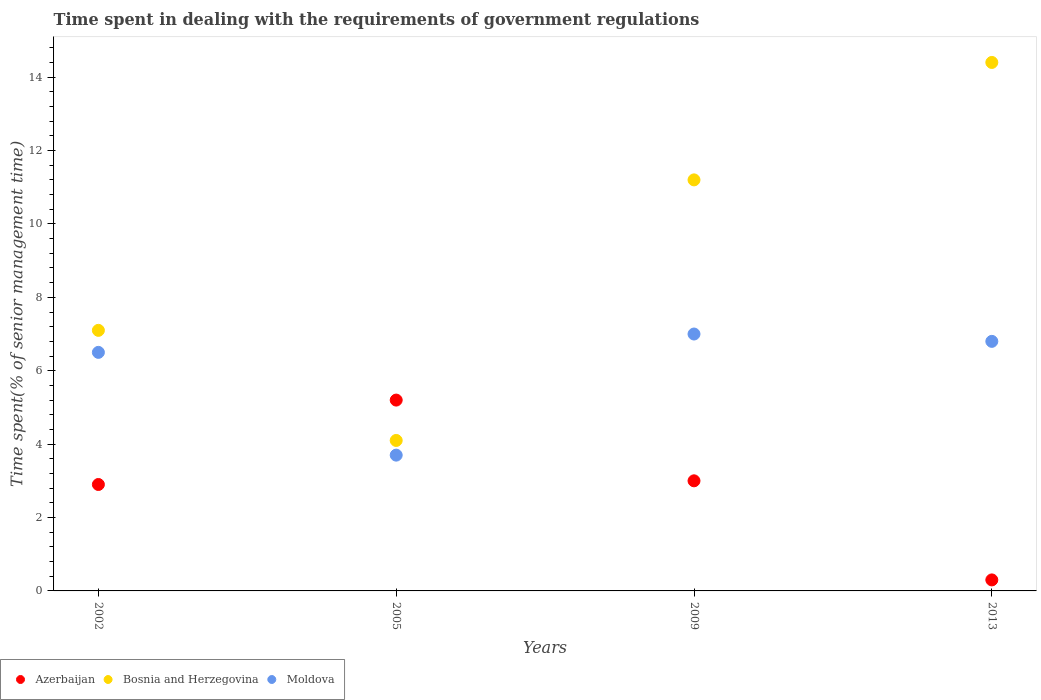How many different coloured dotlines are there?
Your answer should be very brief. 3. Is the number of dotlines equal to the number of legend labels?
Provide a succinct answer. Yes. Across all years, what is the minimum time spent while dealing with the requirements of government regulations in Moldova?
Your answer should be compact. 3.7. In how many years, is the time spent while dealing with the requirements of government regulations in Moldova greater than 0.8 %?
Keep it short and to the point. 4. Is the time spent while dealing with the requirements of government regulations in Moldova in 2002 less than that in 2013?
Offer a terse response. Yes. Is the difference between the time spent while dealing with the requirements of government regulations in Moldova in 2009 and 2013 greater than the difference between the time spent while dealing with the requirements of government regulations in Azerbaijan in 2009 and 2013?
Offer a terse response. No. What is the difference between the highest and the second highest time spent while dealing with the requirements of government regulations in Bosnia and Herzegovina?
Give a very brief answer. 3.2. Is the sum of the time spent while dealing with the requirements of government regulations in Bosnia and Herzegovina in 2002 and 2005 greater than the maximum time spent while dealing with the requirements of government regulations in Azerbaijan across all years?
Your response must be concise. Yes. How many dotlines are there?
Your answer should be compact. 3. What is the difference between two consecutive major ticks on the Y-axis?
Your response must be concise. 2. Does the graph contain any zero values?
Your response must be concise. No. Where does the legend appear in the graph?
Your answer should be compact. Bottom left. How many legend labels are there?
Offer a very short reply. 3. How are the legend labels stacked?
Keep it short and to the point. Horizontal. What is the title of the graph?
Give a very brief answer. Time spent in dealing with the requirements of government regulations. What is the label or title of the X-axis?
Your answer should be very brief. Years. What is the label or title of the Y-axis?
Offer a terse response. Time spent(% of senior management time). What is the Time spent(% of senior management time) in Bosnia and Herzegovina in 2002?
Your answer should be very brief. 7.1. What is the Time spent(% of senior management time) in Azerbaijan in 2005?
Provide a succinct answer. 5.2. What is the Time spent(% of senior management time) in Moldova in 2005?
Provide a succinct answer. 3.7. What is the Time spent(% of senior management time) of Azerbaijan in 2009?
Offer a very short reply. 3. What is the Time spent(% of senior management time) in Bosnia and Herzegovina in 2009?
Make the answer very short. 11.2. What is the Time spent(% of senior management time) in Moldova in 2009?
Offer a very short reply. 7. What is the Time spent(% of senior management time) of Azerbaijan in 2013?
Offer a terse response. 0.3. What is the Time spent(% of senior management time) in Bosnia and Herzegovina in 2013?
Keep it short and to the point. 14.4. Across all years, what is the maximum Time spent(% of senior management time) in Azerbaijan?
Make the answer very short. 5.2. Across all years, what is the maximum Time spent(% of senior management time) of Bosnia and Herzegovina?
Give a very brief answer. 14.4. Across all years, what is the maximum Time spent(% of senior management time) in Moldova?
Offer a terse response. 7. Across all years, what is the minimum Time spent(% of senior management time) of Bosnia and Herzegovina?
Your response must be concise. 4.1. What is the total Time spent(% of senior management time) of Azerbaijan in the graph?
Offer a terse response. 11.4. What is the total Time spent(% of senior management time) in Bosnia and Herzegovina in the graph?
Keep it short and to the point. 36.8. What is the difference between the Time spent(% of senior management time) of Moldova in 2002 and that in 2009?
Keep it short and to the point. -0.5. What is the difference between the Time spent(% of senior management time) in Azerbaijan in 2002 and that in 2013?
Keep it short and to the point. 2.6. What is the difference between the Time spent(% of senior management time) of Bosnia and Herzegovina in 2005 and that in 2009?
Your answer should be compact. -7.1. What is the difference between the Time spent(% of senior management time) of Moldova in 2005 and that in 2009?
Your answer should be compact. -3.3. What is the difference between the Time spent(% of senior management time) in Bosnia and Herzegovina in 2005 and that in 2013?
Provide a short and direct response. -10.3. What is the difference between the Time spent(% of senior management time) in Azerbaijan in 2009 and that in 2013?
Your response must be concise. 2.7. What is the difference between the Time spent(% of senior management time) of Bosnia and Herzegovina in 2009 and that in 2013?
Provide a short and direct response. -3.2. What is the difference between the Time spent(% of senior management time) of Moldova in 2009 and that in 2013?
Make the answer very short. 0.2. What is the difference between the Time spent(% of senior management time) of Azerbaijan in 2002 and the Time spent(% of senior management time) of Bosnia and Herzegovina in 2005?
Your answer should be very brief. -1.2. What is the difference between the Time spent(% of senior management time) of Azerbaijan in 2002 and the Time spent(% of senior management time) of Moldova in 2009?
Keep it short and to the point. -4.1. What is the difference between the Time spent(% of senior management time) of Bosnia and Herzegovina in 2002 and the Time spent(% of senior management time) of Moldova in 2009?
Offer a terse response. 0.1. What is the difference between the Time spent(% of senior management time) of Azerbaijan in 2005 and the Time spent(% of senior management time) of Moldova in 2009?
Your response must be concise. -1.8. What is the difference between the Time spent(% of senior management time) in Bosnia and Herzegovina in 2005 and the Time spent(% of senior management time) in Moldova in 2009?
Your response must be concise. -2.9. What is the difference between the Time spent(% of senior management time) of Azerbaijan in 2005 and the Time spent(% of senior management time) of Bosnia and Herzegovina in 2013?
Provide a succinct answer. -9.2. What is the difference between the Time spent(% of senior management time) of Azerbaijan in 2009 and the Time spent(% of senior management time) of Moldova in 2013?
Your response must be concise. -3.8. What is the average Time spent(% of senior management time) of Azerbaijan per year?
Offer a terse response. 2.85. In the year 2002, what is the difference between the Time spent(% of senior management time) in Azerbaijan and Time spent(% of senior management time) in Bosnia and Herzegovina?
Your answer should be compact. -4.2. In the year 2002, what is the difference between the Time spent(% of senior management time) in Azerbaijan and Time spent(% of senior management time) in Moldova?
Offer a very short reply. -3.6. In the year 2002, what is the difference between the Time spent(% of senior management time) in Bosnia and Herzegovina and Time spent(% of senior management time) in Moldova?
Your answer should be compact. 0.6. In the year 2005, what is the difference between the Time spent(% of senior management time) of Azerbaijan and Time spent(% of senior management time) of Moldova?
Make the answer very short. 1.5. In the year 2005, what is the difference between the Time spent(% of senior management time) of Bosnia and Herzegovina and Time spent(% of senior management time) of Moldova?
Offer a terse response. 0.4. In the year 2013, what is the difference between the Time spent(% of senior management time) in Azerbaijan and Time spent(% of senior management time) in Bosnia and Herzegovina?
Offer a terse response. -14.1. What is the ratio of the Time spent(% of senior management time) in Azerbaijan in 2002 to that in 2005?
Provide a short and direct response. 0.56. What is the ratio of the Time spent(% of senior management time) in Bosnia and Herzegovina in 2002 to that in 2005?
Your answer should be compact. 1.73. What is the ratio of the Time spent(% of senior management time) of Moldova in 2002 to that in 2005?
Ensure brevity in your answer.  1.76. What is the ratio of the Time spent(% of senior management time) in Azerbaijan in 2002 to that in 2009?
Make the answer very short. 0.97. What is the ratio of the Time spent(% of senior management time) in Bosnia and Herzegovina in 2002 to that in 2009?
Offer a very short reply. 0.63. What is the ratio of the Time spent(% of senior management time) of Azerbaijan in 2002 to that in 2013?
Your answer should be compact. 9.67. What is the ratio of the Time spent(% of senior management time) in Bosnia and Herzegovina in 2002 to that in 2013?
Your answer should be very brief. 0.49. What is the ratio of the Time spent(% of senior management time) of Moldova in 2002 to that in 2013?
Give a very brief answer. 0.96. What is the ratio of the Time spent(% of senior management time) of Azerbaijan in 2005 to that in 2009?
Provide a succinct answer. 1.73. What is the ratio of the Time spent(% of senior management time) of Bosnia and Herzegovina in 2005 to that in 2009?
Your answer should be compact. 0.37. What is the ratio of the Time spent(% of senior management time) of Moldova in 2005 to that in 2009?
Your answer should be compact. 0.53. What is the ratio of the Time spent(% of senior management time) in Azerbaijan in 2005 to that in 2013?
Ensure brevity in your answer.  17.33. What is the ratio of the Time spent(% of senior management time) in Bosnia and Herzegovina in 2005 to that in 2013?
Provide a succinct answer. 0.28. What is the ratio of the Time spent(% of senior management time) in Moldova in 2005 to that in 2013?
Your answer should be compact. 0.54. What is the ratio of the Time spent(% of senior management time) of Bosnia and Herzegovina in 2009 to that in 2013?
Your response must be concise. 0.78. What is the ratio of the Time spent(% of senior management time) of Moldova in 2009 to that in 2013?
Your answer should be very brief. 1.03. What is the difference between the highest and the second highest Time spent(% of senior management time) in Azerbaijan?
Keep it short and to the point. 2.2. 